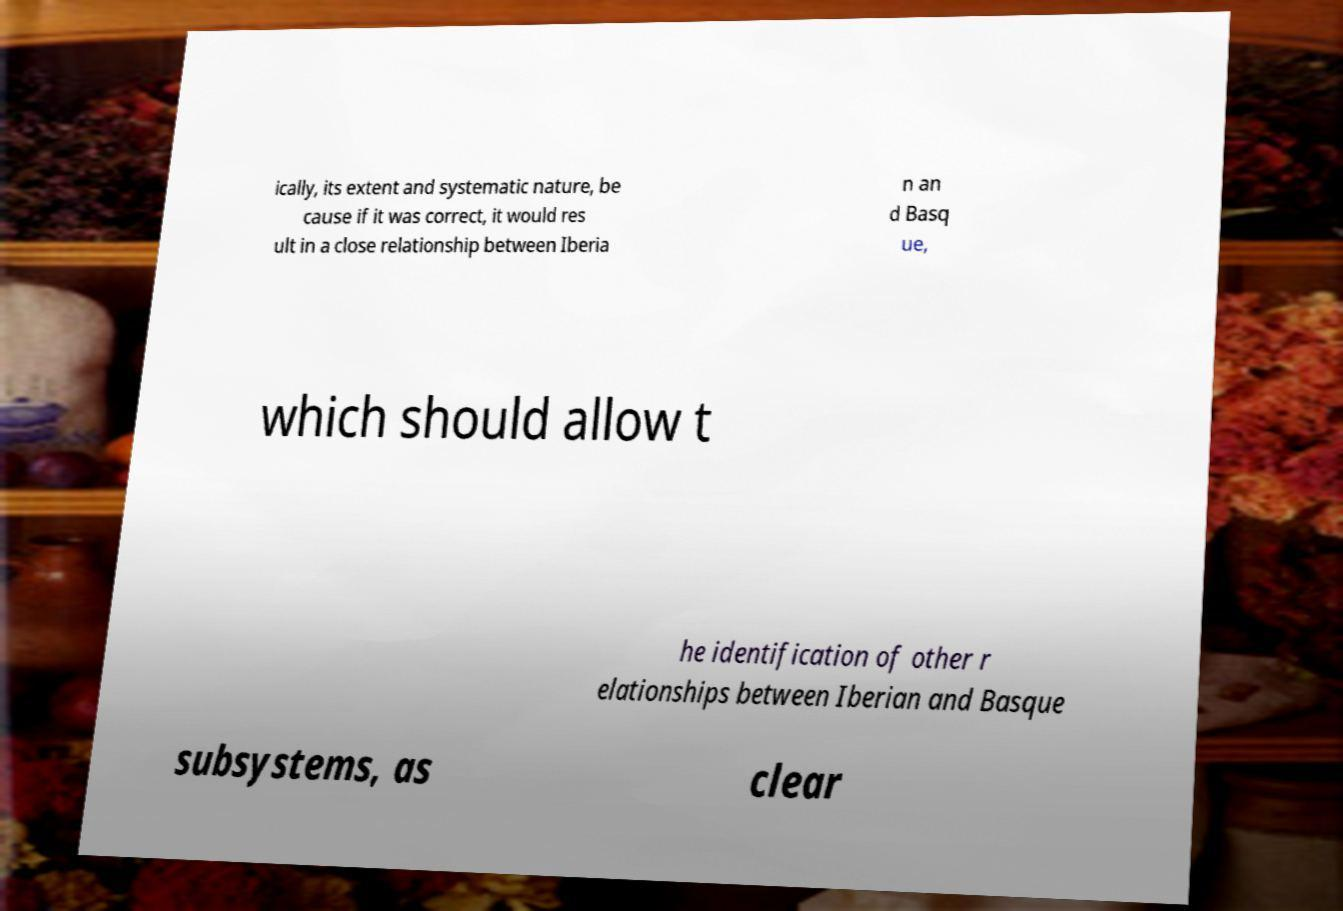Please read and relay the text visible in this image. What does it say? ically, its extent and systematic nature, be cause if it was correct, it would res ult in a close relationship between Iberia n an d Basq ue, which should allow t he identification of other r elationships between Iberian and Basque subsystems, as clear 